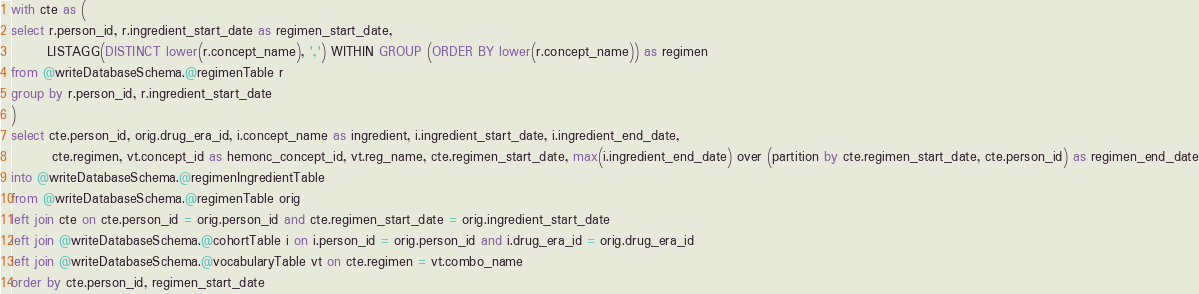<code> <loc_0><loc_0><loc_500><loc_500><_SQL_>with cte as (
select r.person_id, r.ingredient_start_date as regimen_start_date,
       LISTAGG(DISTINCT lower(r.concept_name), ',') WITHIN GROUP (ORDER BY lower(r.concept_name)) as regimen
from @writeDatabaseSchema.@regimenTable r
group by r.person_id, r.ingredient_start_date
)
select cte.person_id, orig.drug_era_id, i.concept_name as ingredient, i.ingredient_start_date, i.ingredient_end_date,
        cte.regimen, vt.concept_id as hemonc_concept_id, vt.reg_name, cte.regimen_start_date, max(i.ingredient_end_date) over (partition by cte.regimen_start_date, cte.person_id) as regimen_end_date
into @writeDatabaseSchema.@regimenIngredientTable
from @writeDatabaseSchema.@regimenTable orig
left join cte on cte.person_id = orig.person_id and cte.regimen_start_date = orig.ingredient_start_date
left join @writeDatabaseSchema.@cohortTable i on i.person_id = orig.person_id and i.drug_era_id = orig.drug_era_id
left join @writeDatabaseSchema.@vocabularyTable vt on cte.regimen = vt.combo_name
order by cte.person_id, regimen_start_date
</code> 